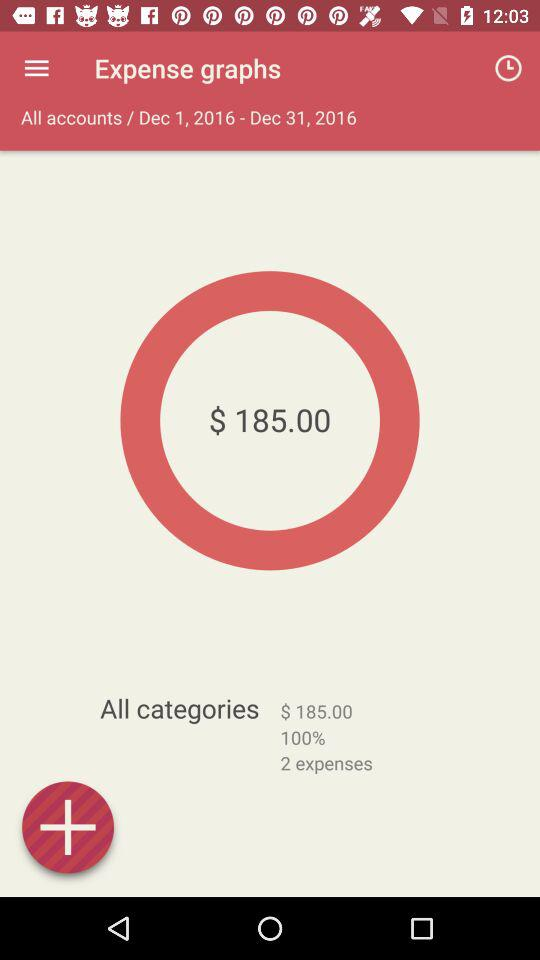How many dollars are in the expense total?
Answer the question using a single word or phrase. $185.00 